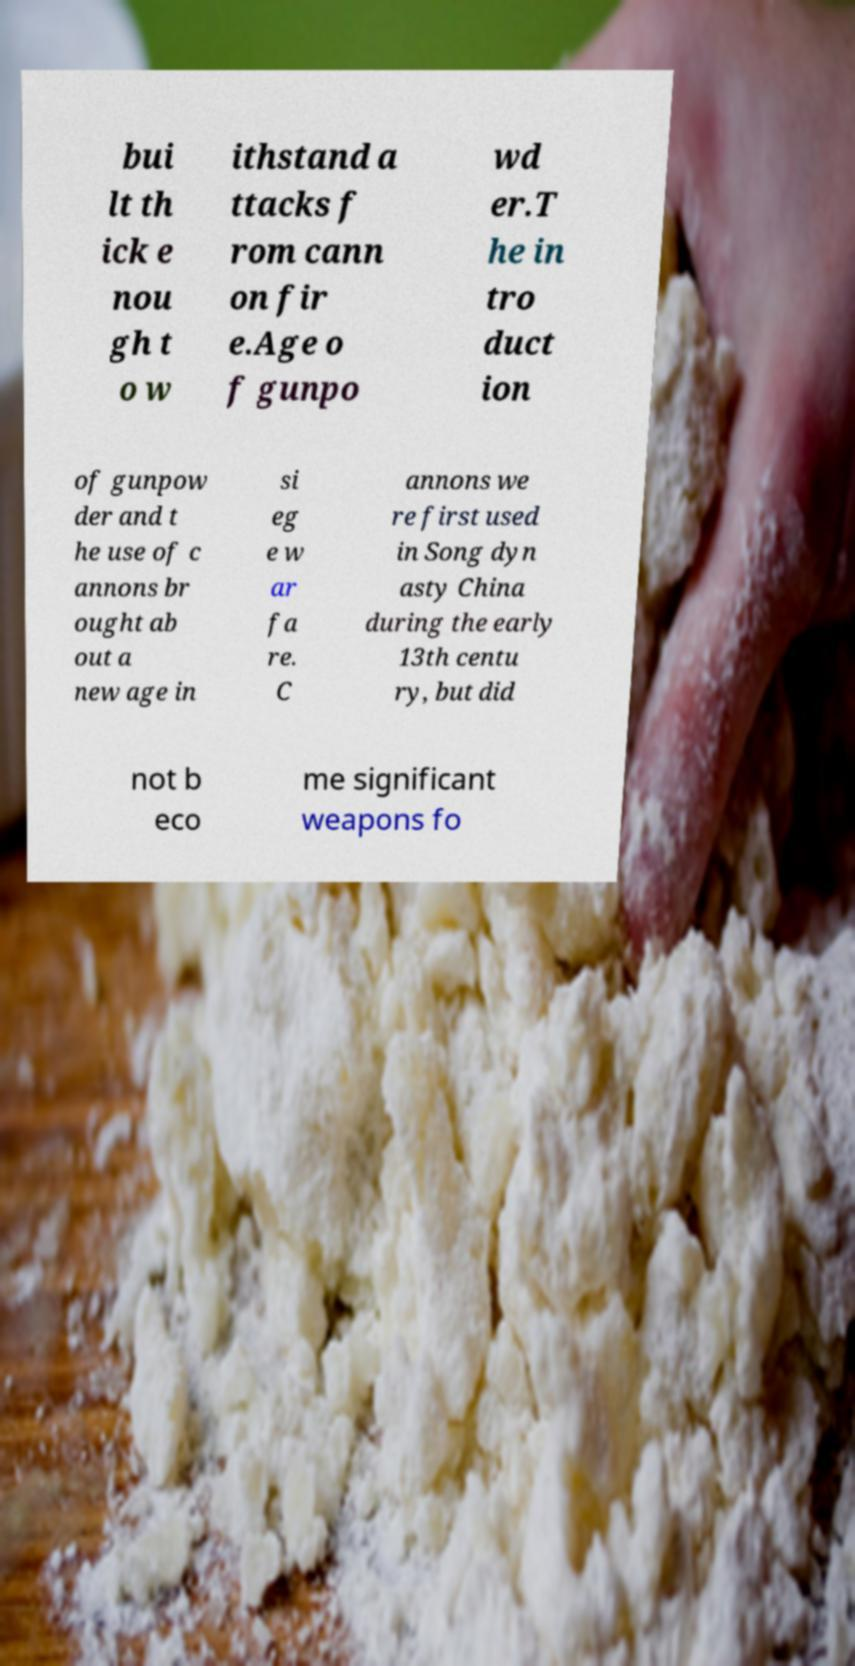Could you extract and type out the text from this image? bui lt th ick e nou gh t o w ithstand a ttacks f rom cann on fir e.Age o f gunpo wd er.T he in tro duct ion of gunpow der and t he use of c annons br ought ab out a new age in si eg e w ar fa re. C annons we re first used in Song dyn asty China during the early 13th centu ry, but did not b eco me significant weapons fo 